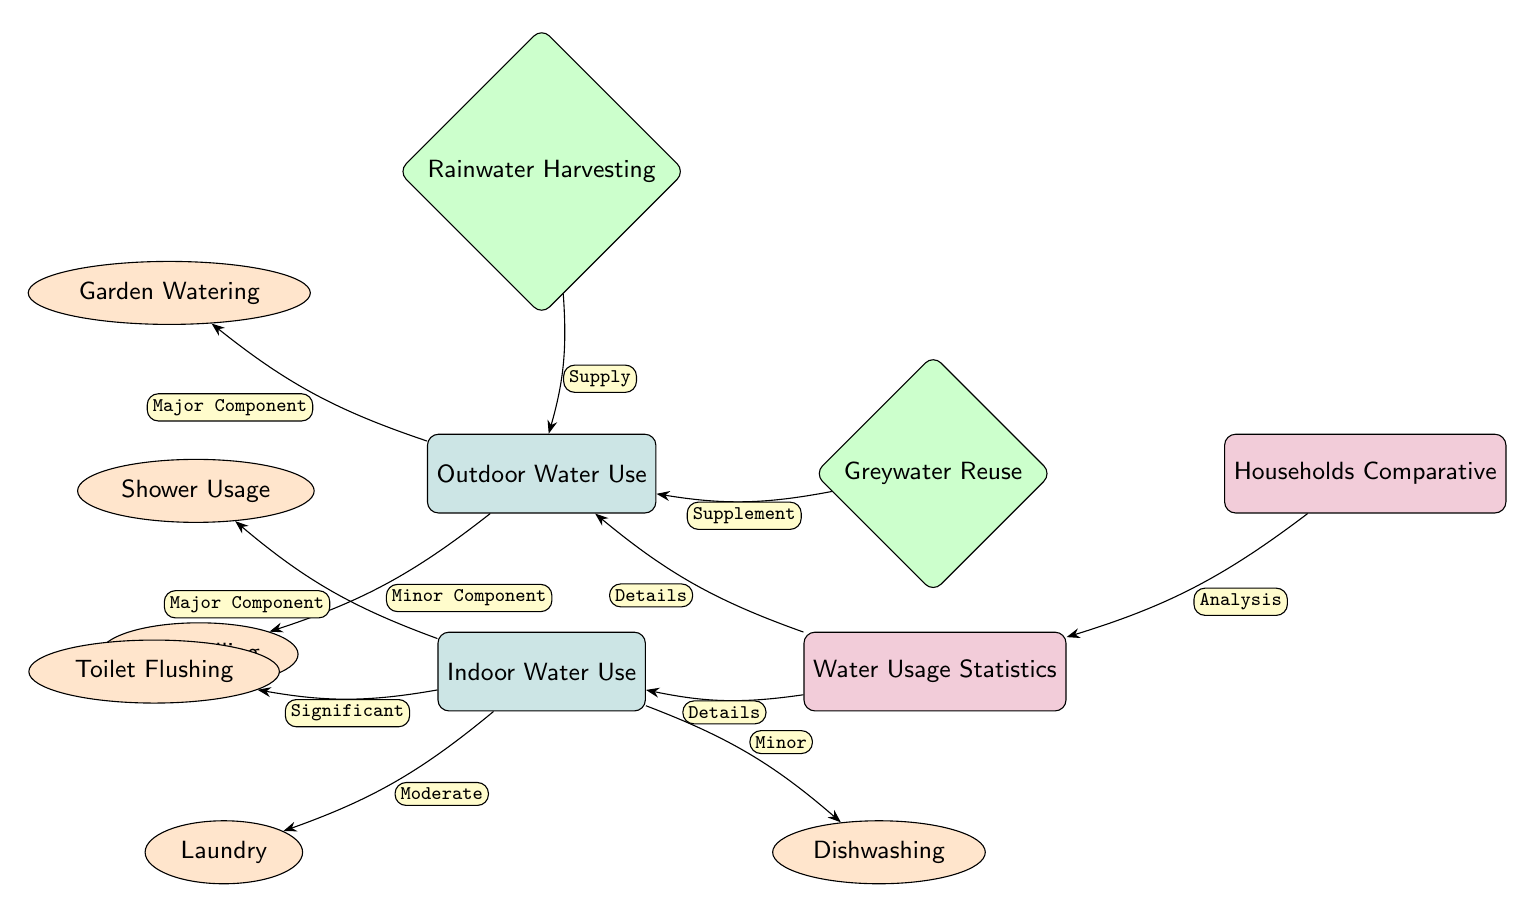What are the two main categories of water use depicted in the diagram? The diagram clearly shows two main categories of water use, which are indicated by the two main nodes: "Outdoor Water Use" and "Indoor Water Use."
Answer: Outdoor Water Use, Indoor Water Use Which outdoor water use component is indicated as a major component? The diagram specifies that "Garden Watering" is labeled as a "Major Component," while "Pool Filling" is labeled as a "Minor Component."
Answer: Garden Watering How many indoor sub-nodes are connected to indoor water use? There are four sub-nodes connected to "Indoor Water Use": "Shower Usage," "Toilet Flushing," "Laundry," and "Dishwashing." Therefore, the total is four.
Answer: Four What connection type exists between rainwater harvesting and outdoor water use? The diagram specifies the relationship as "Supply," indicating that rainwater harvesting provides supply for outdoor water use.
Answer: Supply What does the edge titled "Analysis" indicate in relation to the statistics? The edge titled "Analysis" connects the "Households Comparative" node to the "Water Usage Statistics" node, indicating a relationship where analysis is conducted based on the statistics of water use.
Answer: Analysis Which indoor water use component is marked as having a significant relationship? The "Toilet Flushing" sub-node is marked as having a "Significant" relationship to the main "Indoor Water Use" node, highlighting its importance in water consumption.
Answer: Toilet Flushing What is indicated as a supplement to outdoor water use? The diagram labels "Greywater Reuse" as a "Supplement," meaning it assists or enhances outdoor water use without being the primary source.
Answer: Greywater Reuse How many total edges are present in the diagram? Counting the edges from the diagram data provided: there are eight edges connecting various components, including major, significant, and minor relations.
Answer: Eight 